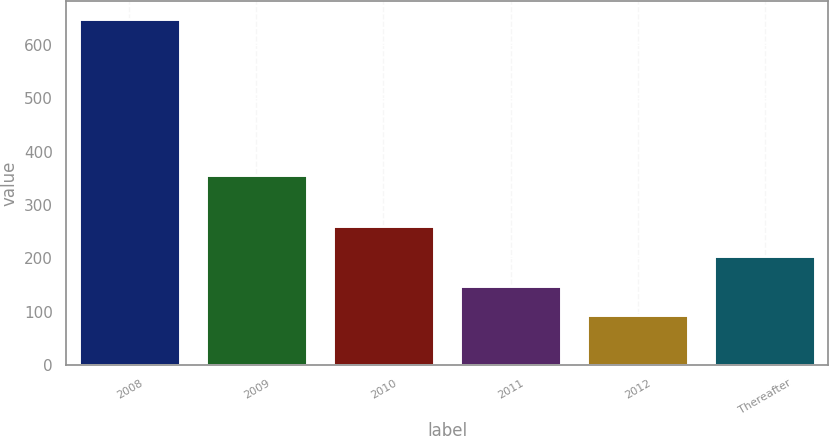Convert chart. <chart><loc_0><loc_0><loc_500><loc_500><bar_chart><fcel>2008<fcel>2009<fcel>2010<fcel>2011<fcel>2012<fcel>Thereafter<nl><fcel>650<fcel>357<fcel>260.1<fcel>148.7<fcel>93<fcel>204.4<nl></chart> 